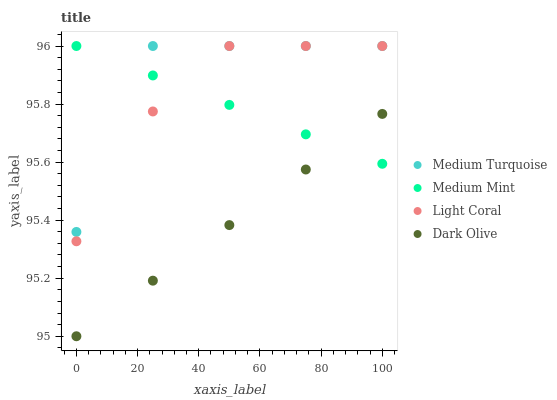Does Dark Olive have the minimum area under the curve?
Answer yes or no. Yes. Does Medium Turquoise have the maximum area under the curve?
Answer yes or no. Yes. Does Light Coral have the minimum area under the curve?
Answer yes or no. No. Does Light Coral have the maximum area under the curve?
Answer yes or no. No. Is Medium Mint the smoothest?
Answer yes or no. Yes. Is Medium Turquoise the roughest?
Answer yes or no. Yes. Is Light Coral the smoothest?
Answer yes or no. No. Is Light Coral the roughest?
Answer yes or no. No. Does Dark Olive have the lowest value?
Answer yes or no. Yes. Does Light Coral have the lowest value?
Answer yes or no. No. Does Medium Turquoise have the highest value?
Answer yes or no. Yes. Does Dark Olive have the highest value?
Answer yes or no. No. Is Dark Olive less than Medium Turquoise?
Answer yes or no. Yes. Is Light Coral greater than Dark Olive?
Answer yes or no. Yes. Does Medium Mint intersect Medium Turquoise?
Answer yes or no. Yes. Is Medium Mint less than Medium Turquoise?
Answer yes or no. No. Is Medium Mint greater than Medium Turquoise?
Answer yes or no. No. Does Dark Olive intersect Medium Turquoise?
Answer yes or no. No. 